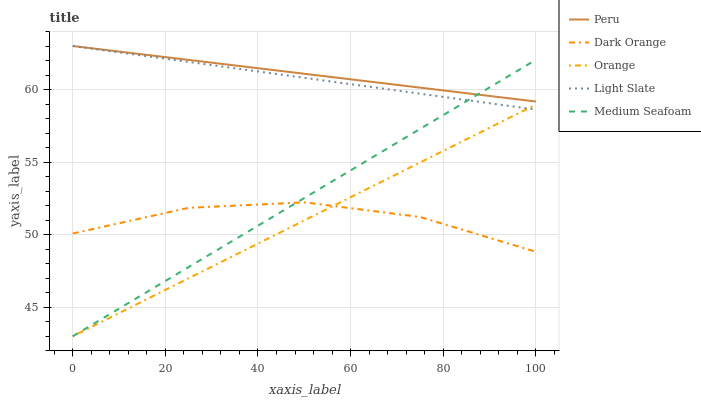Does Orange have the minimum area under the curve?
Answer yes or no. Yes. Does Peru have the maximum area under the curve?
Answer yes or no. Yes. Does Dark Orange have the minimum area under the curve?
Answer yes or no. No. Does Dark Orange have the maximum area under the curve?
Answer yes or no. No. Is Orange the smoothest?
Answer yes or no. Yes. Is Dark Orange the roughest?
Answer yes or no. Yes. Is Light Slate the smoothest?
Answer yes or no. No. Is Light Slate the roughest?
Answer yes or no. No. Does Dark Orange have the lowest value?
Answer yes or no. No. Does Peru have the highest value?
Answer yes or no. Yes. Does Dark Orange have the highest value?
Answer yes or no. No. Is Orange less than Peru?
Answer yes or no. Yes. Is Peru greater than Orange?
Answer yes or no. Yes. Does Medium Seafoam intersect Peru?
Answer yes or no. Yes. Is Medium Seafoam less than Peru?
Answer yes or no. No. Is Medium Seafoam greater than Peru?
Answer yes or no. No. Does Orange intersect Peru?
Answer yes or no. No. 